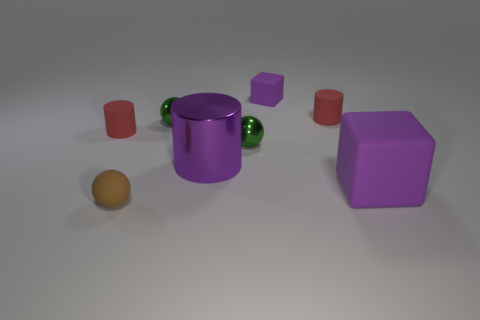Add 1 yellow rubber spheres. How many objects exist? 9 Subtract all cylinders. How many objects are left? 5 Subtract all small red objects. Subtract all large cylinders. How many objects are left? 5 Add 6 red matte objects. How many red matte objects are left? 8 Add 1 gray objects. How many gray objects exist? 1 Subtract 0 purple spheres. How many objects are left? 8 